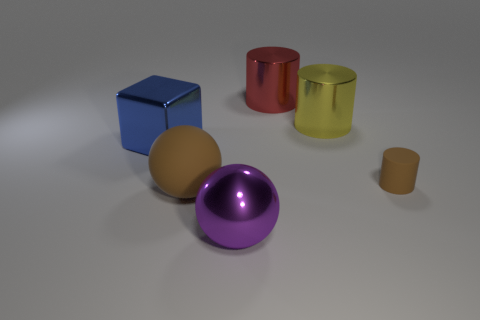Is the number of red objects right of the matte cylinder the same as the number of large yellow matte balls? yes 